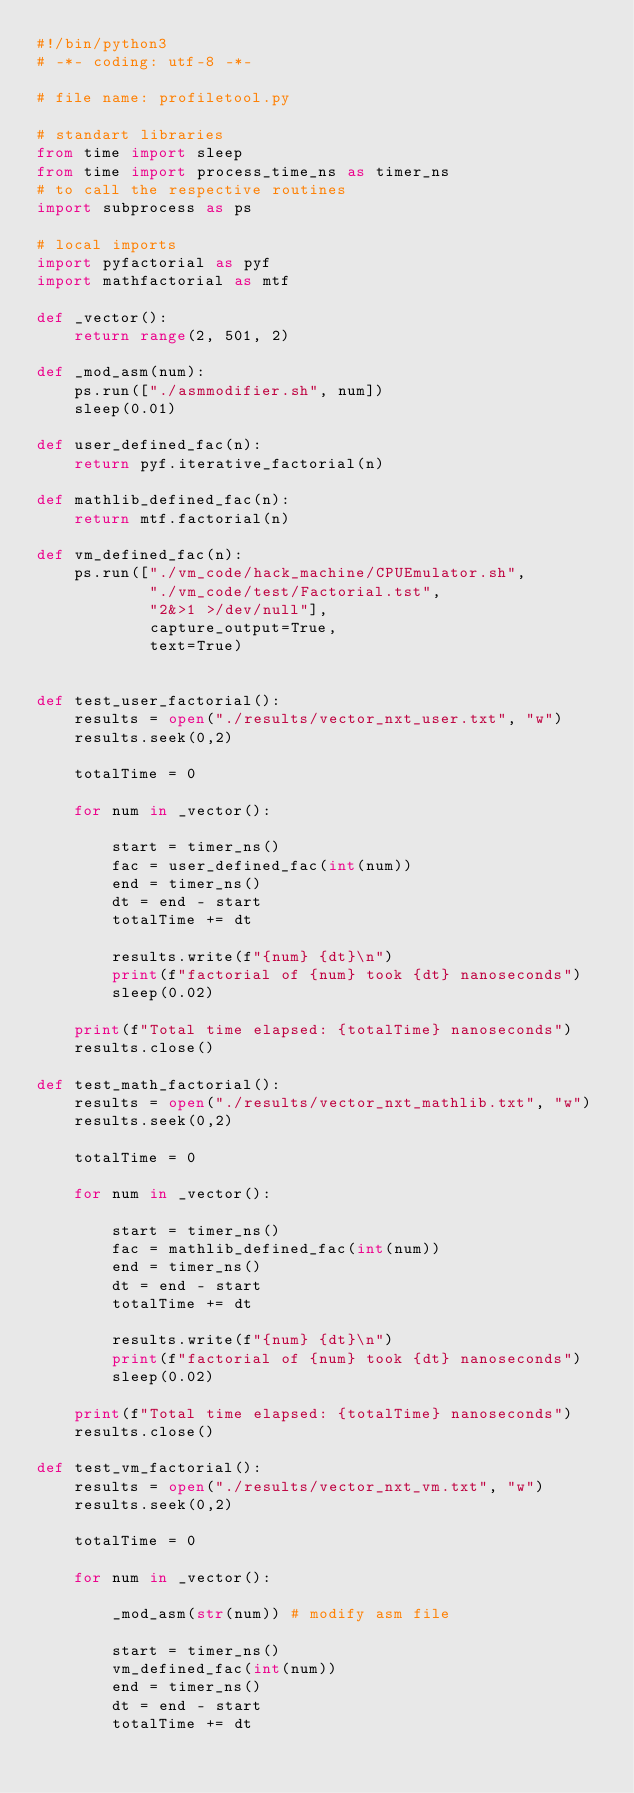<code> <loc_0><loc_0><loc_500><loc_500><_Python_>#!/bin/python3
# -*- coding: utf-8 -*-

# file name: profiletool.py

# standart libraries
from time import sleep
from time import process_time_ns as timer_ns
# to call the respective routines
import subprocess as ps

# local imports
import pyfactorial as pyf
import mathfactorial as mtf

def _vector():
    return range(2, 501, 2)

def _mod_asm(num):
    ps.run(["./asmmodifier.sh", num])
    sleep(0.01)

def user_defined_fac(n):
    return pyf.iterative_factorial(n)

def mathlib_defined_fac(n):
    return mtf.factorial(n)

def vm_defined_fac(n):
    ps.run(["./vm_code/hack_machine/CPUEmulator.sh",
            "./vm_code/test/Factorial.tst",
            "2&>1 >/dev/null"],
            capture_output=True,
            text=True)


def test_user_factorial():
    results = open("./results/vector_nxt_user.txt", "w")
    results.seek(0,2)

    totalTime = 0

    for num in _vector():

        start = timer_ns()
        fac = user_defined_fac(int(num))
        end = timer_ns()
        dt = end - start
        totalTime += dt

        results.write(f"{num} {dt}\n")
        print(f"factorial of {num} took {dt} nanoseconds")
        sleep(0.02)

    print(f"Total time elapsed: {totalTime} nanoseconds")
    results.close()

def test_math_factorial():
    results = open("./results/vector_nxt_mathlib.txt", "w")
    results.seek(0,2)

    totalTime = 0

    for num in _vector():

        start = timer_ns()
        fac = mathlib_defined_fac(int(num))
        end = timer_ns()
        dt = end - start
        totalTime += dt

        results.write(f"{num} {dt}\n")
        print(f"factorial of {num} took {dt} nanoseconds")
        sleep(0.02)

    print(f"Total time elapsed: {totalTime} nanoseconds")
    results.close()

def test_vm_factorial():
    results = open("./results/vector_nxt_vm.txt", "w")
    results.seek(0,2)

    totalTime = 0

    for num in _vector():

        _mod_asm(str(num)) # modify asm file

        start = timer_ns()
        vm_defined_fac(int(num))
        end = timer_ns()
        dt = end - start
        totalTime += dt
</code> 